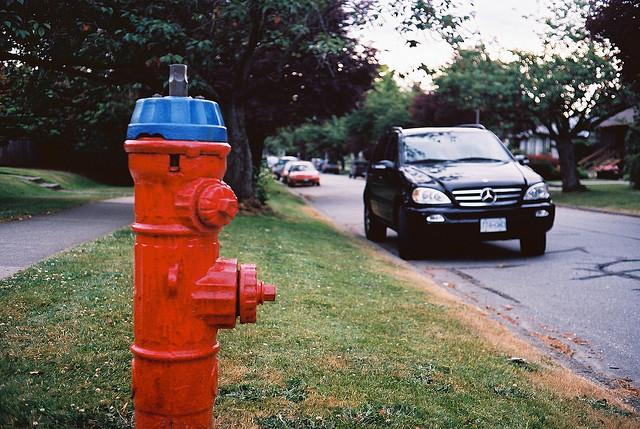Why is the black vehicle stopped near the curb?

Choices:
A) to load
B) to race
C) to deliver
D) to park to park 